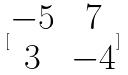Convert formula to latex. <formula><loc_0><loc_0><loc_500><loc_500>[ \begin{matrix} - 5 & 7 \\ 3 & - 4 \end{matrix} ]</formula> 